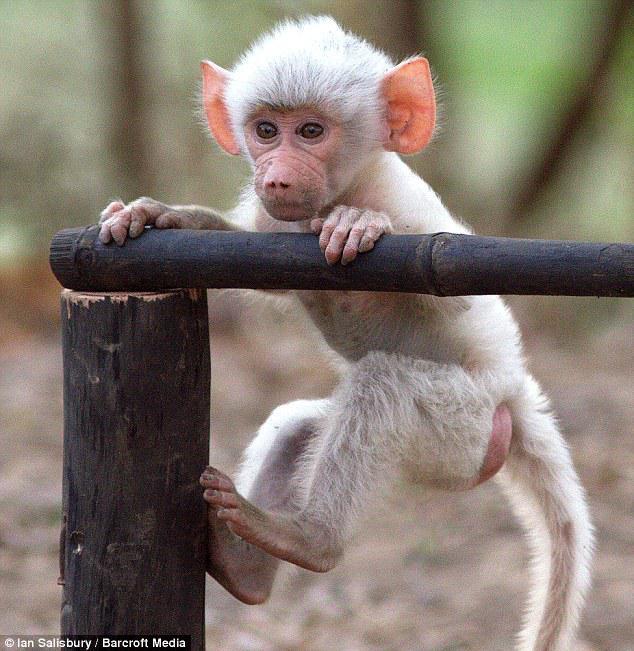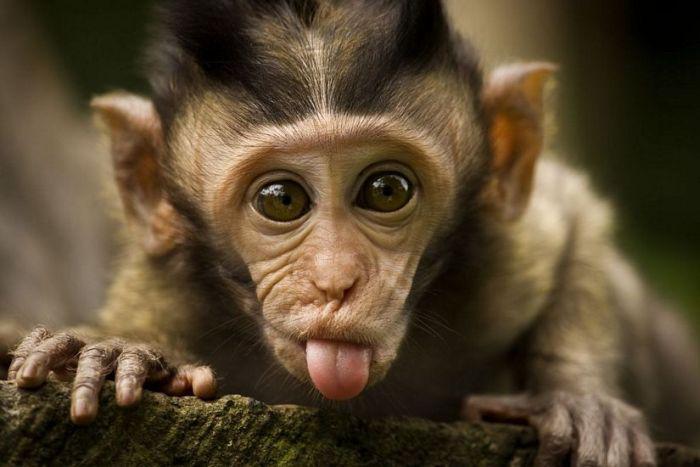The first image is the image on the left, the second image is the image on the right. Examine the images to the left and right. Is the description "There is text in both images." accurate? Answer yes or no. No. The first image is the image on the left, the second image is the image on the right. Given the left and right images, does the statement "Each image contains exactly one monkey, and the monkeys on the right and left are the same approximate age [mature or immature]." hold true? Answer yes or no. Yes. 